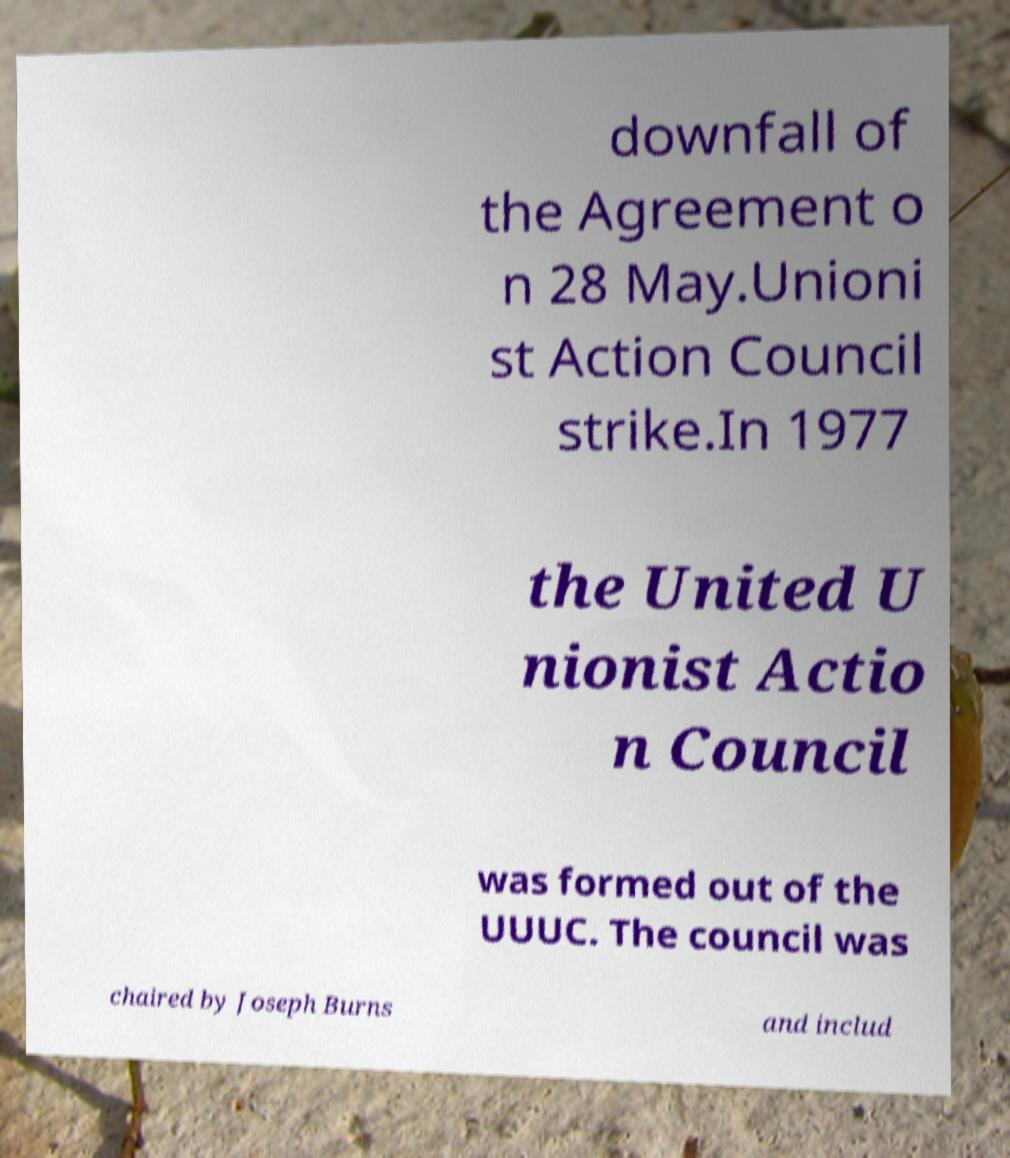I need the written content from this picture converted into text. Can you do that? downfall of the Agreement o n 28 May.Unioni st Action Council strike.In 1977 the United U nionist Actio n Council was formed out of the UUUC. The council was chaired by Joseph Burns and includ 